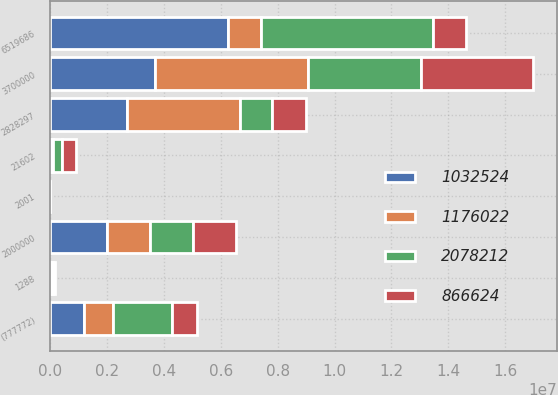<chart> <loc_0><loc_0><loc_500><loc_500><stacked_bar_chart><ecel><fcel>2001<fcel>2828297<fcel>1288<fcel>6519686<fcel>3700000<fcel>2000000<fcel>21602<fcel>(777772)<nl><fcel>1.03252e+06<fcel>2002<fcel>2.687e+06<fcel>9972<fcel>6.26058e+06<fcel>3.7e+06<fcel>2e+06<fcel>47053<fcel>1.17602e+06<nl><fcel>1.17602e+06<fcel>2003<fcel>3.97297e+06<fcel>19974<fcel>1.16583e+06<fcel>5.37835e+06<fcel>1.5e+06<fcel>59322<fcel>1.03252e+06<nl><fcel>2.07821e+06<fcel>2004<fcel>1.15563e+06<fcel>57552<fcel>6.02928e+06<fcel>3.94615e+06<fcel>1.525e+06<fcel>320408<fcel>2.07821e+06<nl><fcel>866624<fcel>2005<fcel>1.18136e+06<fcel>67120<fcel>1.16583e+06<fcel>3.94196e+06<fcel>1.525e+06<fcel>468337<fcel>866624<nl></chart> 